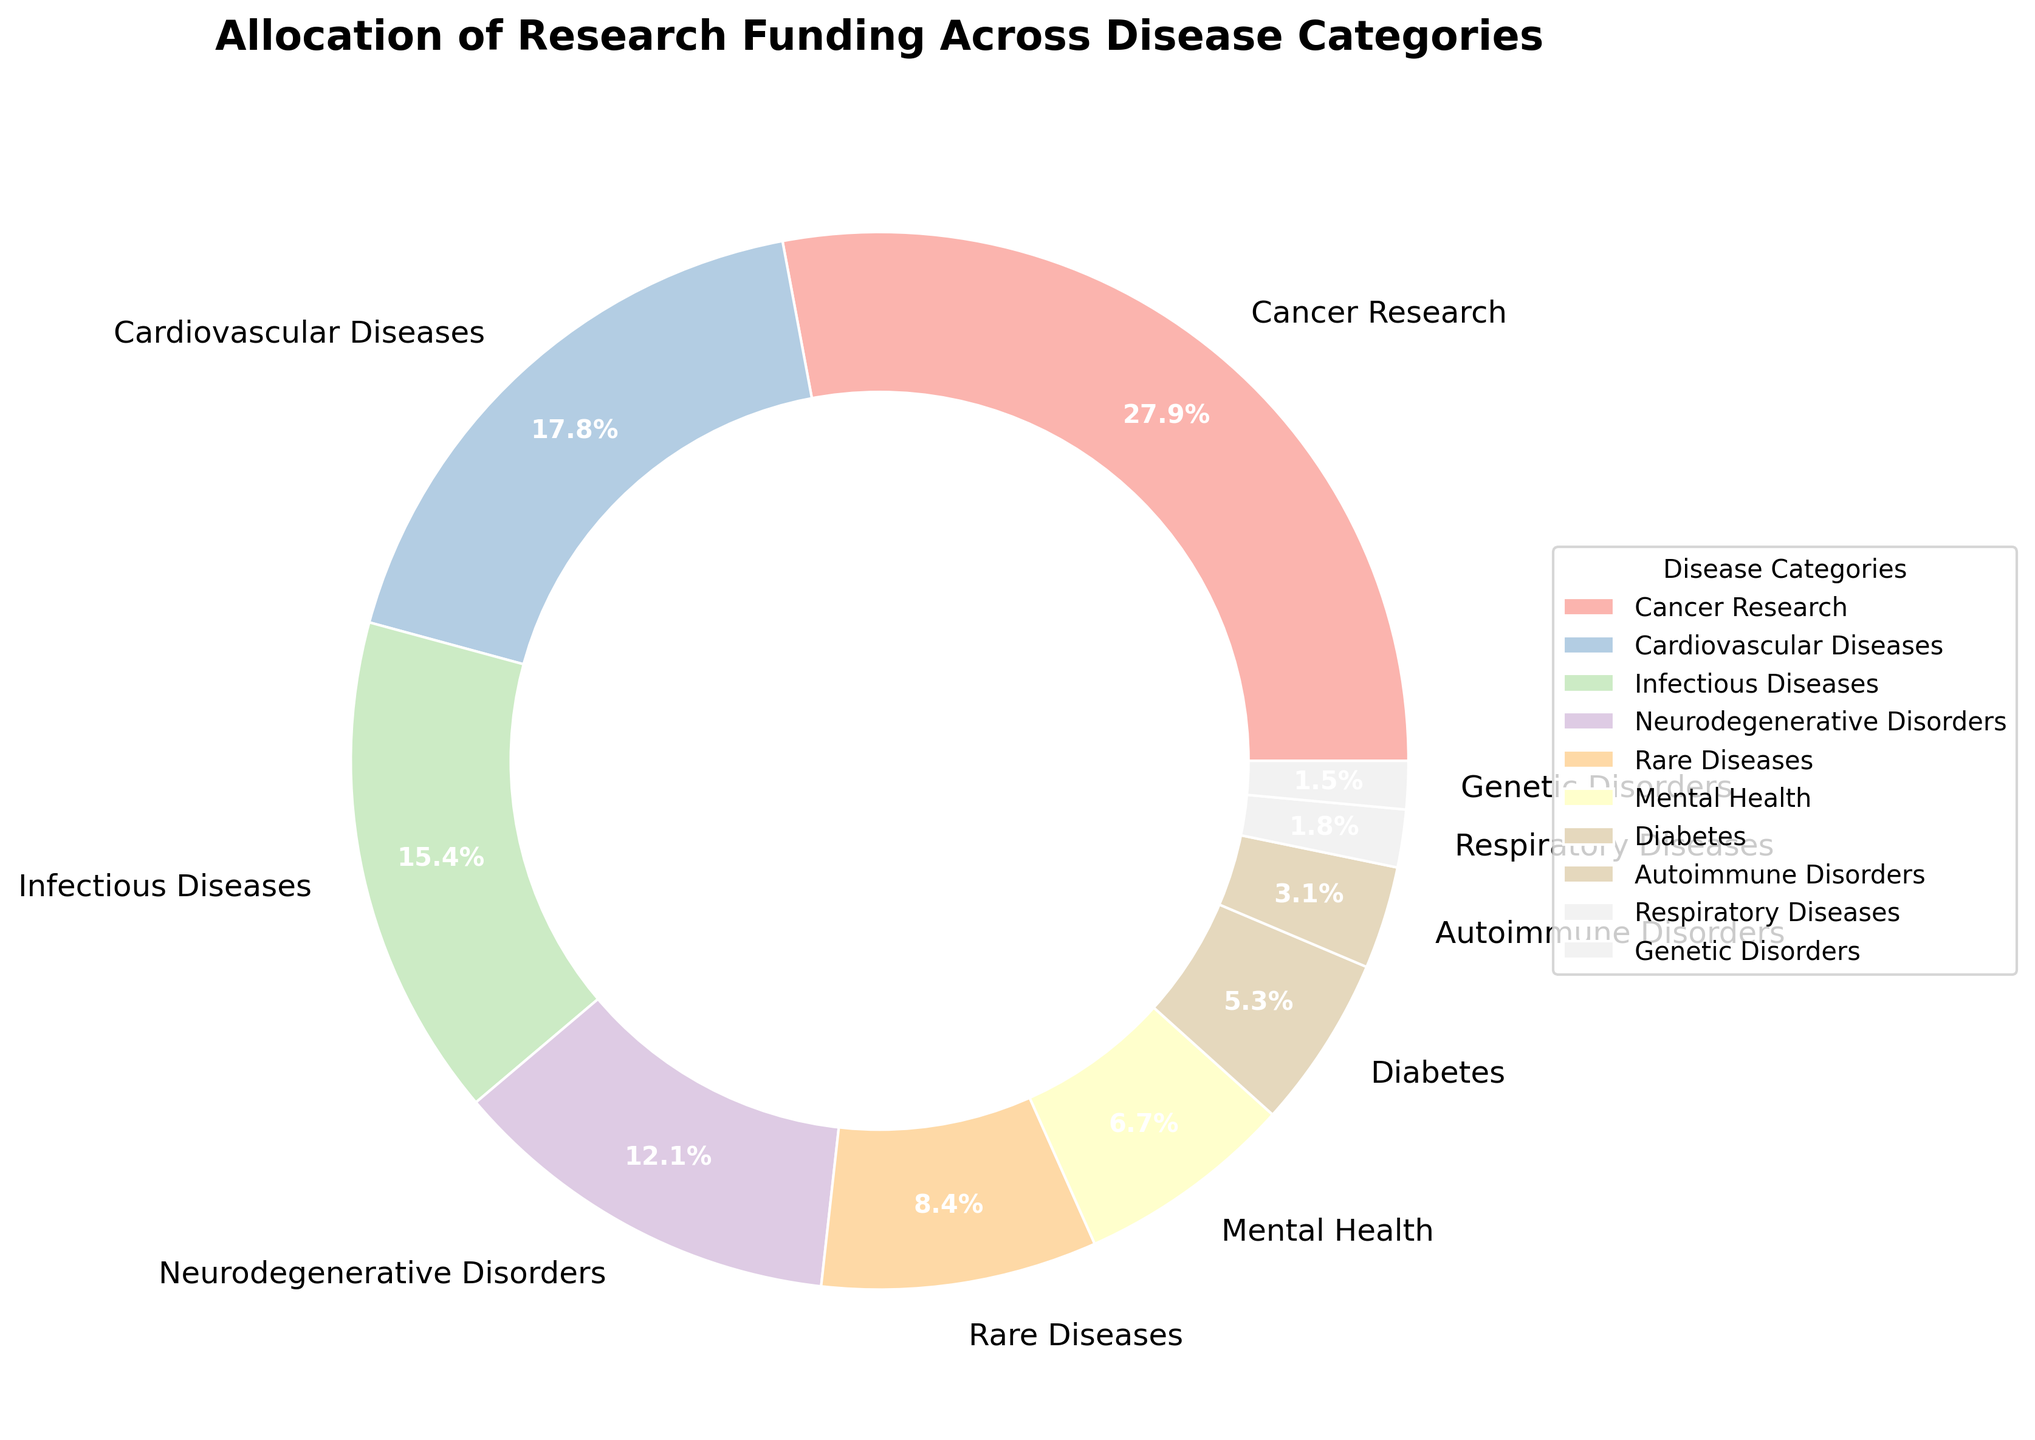Which disease category receives the highest funding allocation? From the pie chart, the largest segment is labeled "Cancer Research," which corresponds to the highest funding allocation.
Answer: Cancer Research Which two disease categories receive almost similar funding allocations, and what are their percentages? From the pie chart, "Infectious Diseases" and "Neurodegenerative Disorders" have segments of similar size. The values are 15.7% for Infectious Diseases and 12.3% for Neurodegenerative Disorders.
Answer: Infectious Diseases: 15.7%, Neurodegenerative Disorders: 12.3% What is the total funding allocation percentage for Cancer Research, Cardiovascular Diseases, and Infectious Diseases combined? To find the total, sum the percentages for Cancer Research (28.5%), Cardiovascular Diseases (18.2%), and Infectious Diseases (15.7%): 28.5 + 18.2 + 15.7 = 62.4%.
Answer: 62.4% How does the funding allocation for Mental Health compare to that for Rare Diseases? The pie chart shows that Rare Diseases receive 8.6%, and Mental Health receives 6.8%. Comparatively, Rare Diseases receive more funding than Mental Health.
Answer: Rare Diseases receive more Which category has the smallest funding allocation, and what is its percentage? The smallest segment in the pie chart corresponds to Genetic Disorders. The funding allocation percentage for Genetic Disorders is 1.5%.
Answer: Genetic Disorders, 1.5% What is the funding allocation difference between Autoimmune Disorders and Respiratory Diseases? The pie chart shows Autoimmune Disorders with 3.2% and Respiratory Diseases with 1.8%. Subtract the smaller percentage from the larger: 3.2 - 1.8 = 1.4%.
Answer: 1.4% How many disease categories have a funding allocation below 10%? From the pie chart, the segments for Rare Diseases, Mental Health, Diabetes, Autoimmune Disorders, Respiratory Diseases, and Genetic Disorders are all below 10%. That totals to 6 categories.
Answer: 6 If two disease categories' funding allocations were combined to exceed Cancer Research's allocation, which ones would they be and what would be the combined percentage? The two closest large segments are Cardiovascular Diseases (18.2%) and Infectious Diseases (15.7%). Combined, this is 18.2 + 15.7 = 33.9%, which exceeds Cancer Research's 28.5%.
Answer: Cardiovascular Diseases and Infectious Diseases, 33.9% What proportion of the total funding is allocated to categories receiving less than 5% each? From the pie chart, categories below 5% are Diabetes (5.4%), Autoimmune Disorders (3.2%), Respiratory Diseases (1.8%), and Genetic Disorders (1.5%). Adding percentages: 5.4 + 3.2 + 1.8 + 1.5 = 11.9%. Note: Since Diabetes is slightly above 5%, if we only consider those below 5%, the total is 3.2 + 1.8 + 1.5 = 6.5%.
Answer: 6.5% 